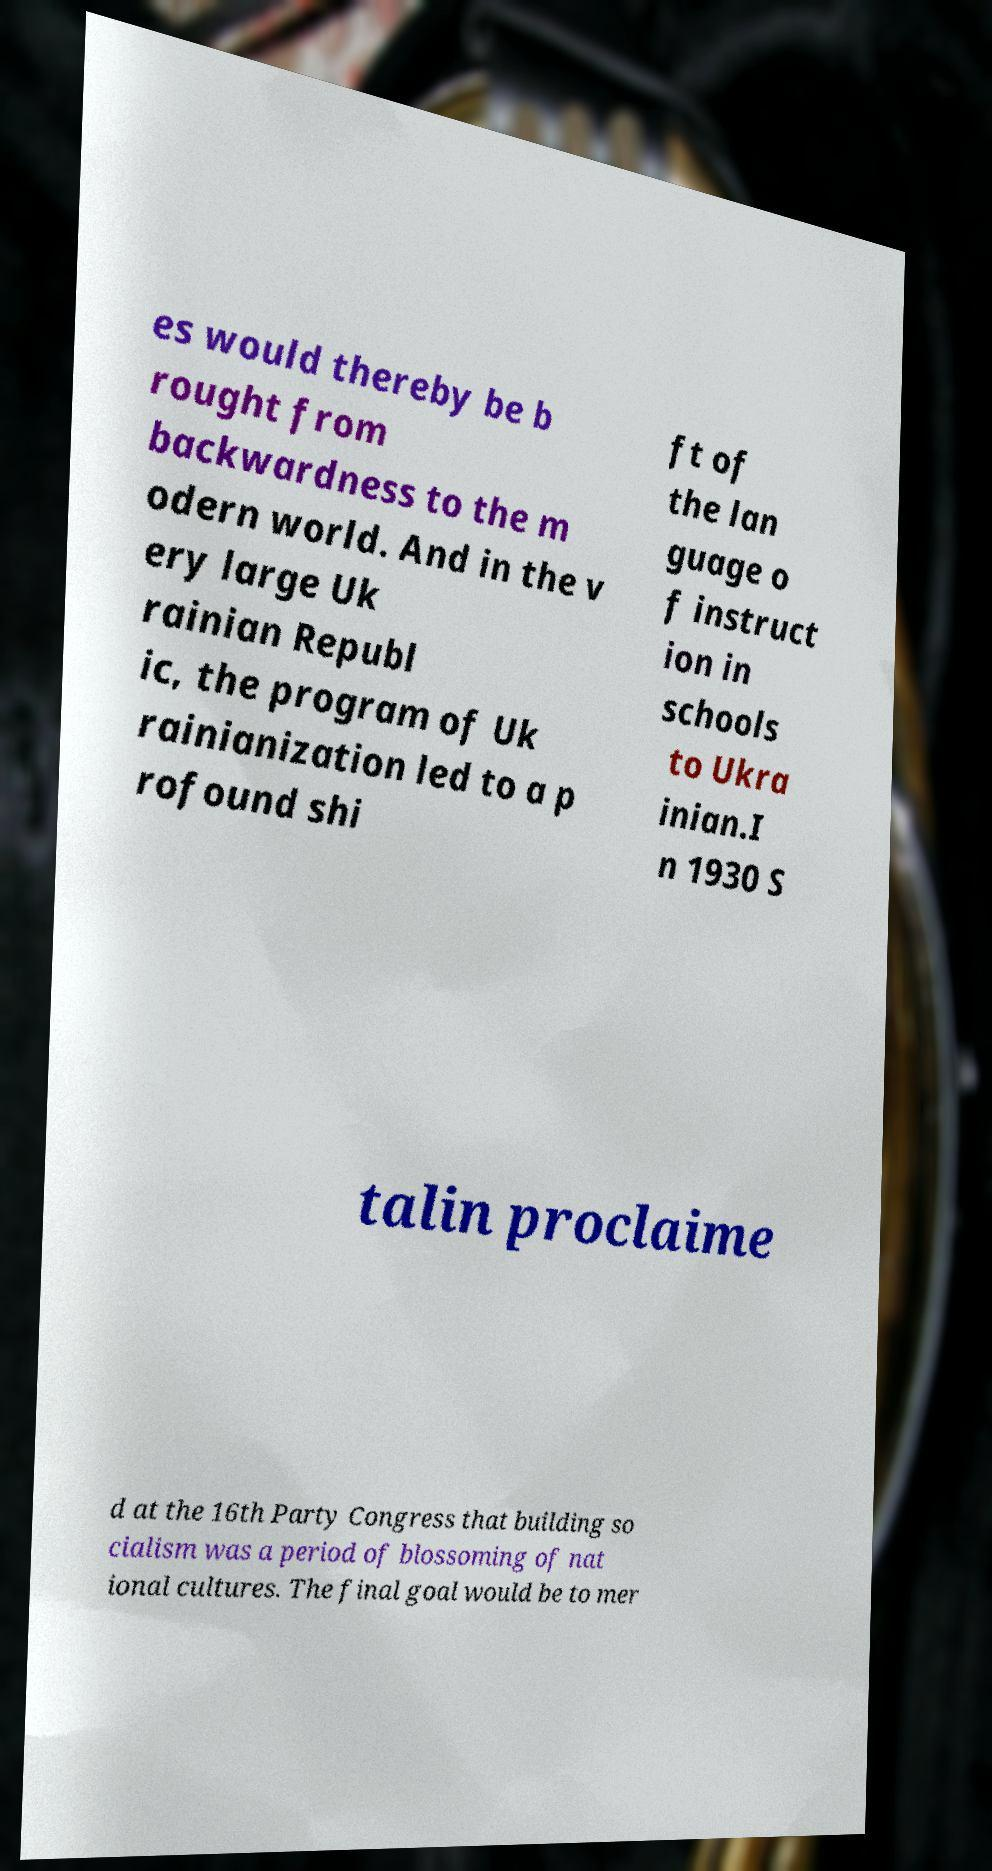Can you accurately transcribe the text from the provided image for me? es would thereby be b rought from backwardness to the m odern world. And in the v ery large Uk rainian Republ ic, the program of Uk rainianization led to a p rofound shi ft of the lan guage o f instruct ion in schools to Ukra inian.I n 1930 S talin proclaime d at the 16th Party Congress that building so cialism was a period of blossoming of nat ional cultures. The final goal would be to mer 